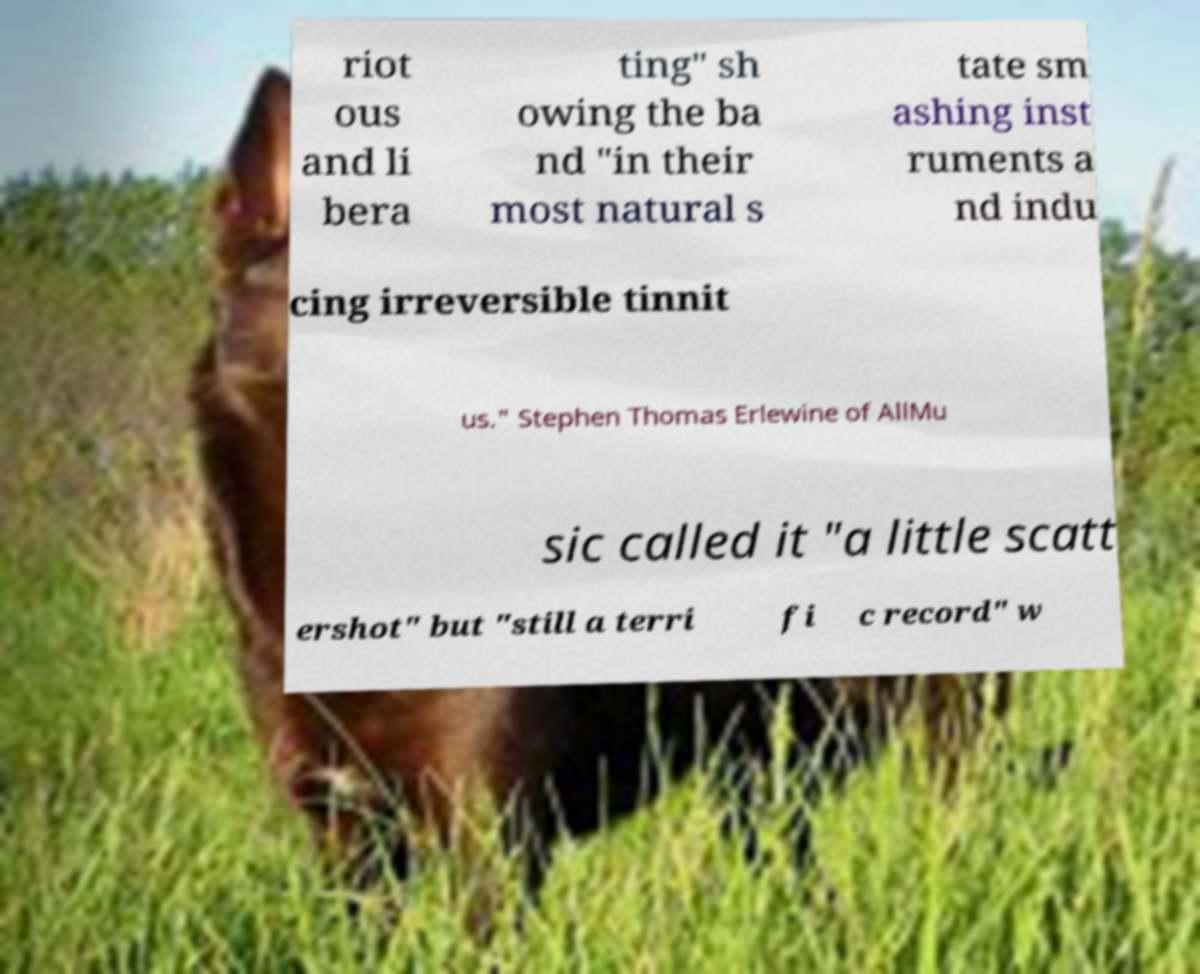Please identify and transcribe the text found in this image. riot ous and li bera ting" sh owing the ba nd "in their most natural s tate sm ashing inst ruments a nd indu cing irreversible tinnit us." Stephen Thomas Erlewine of AllMu sic called it "a little scatt ershot" but "still a terri fi c record" w 